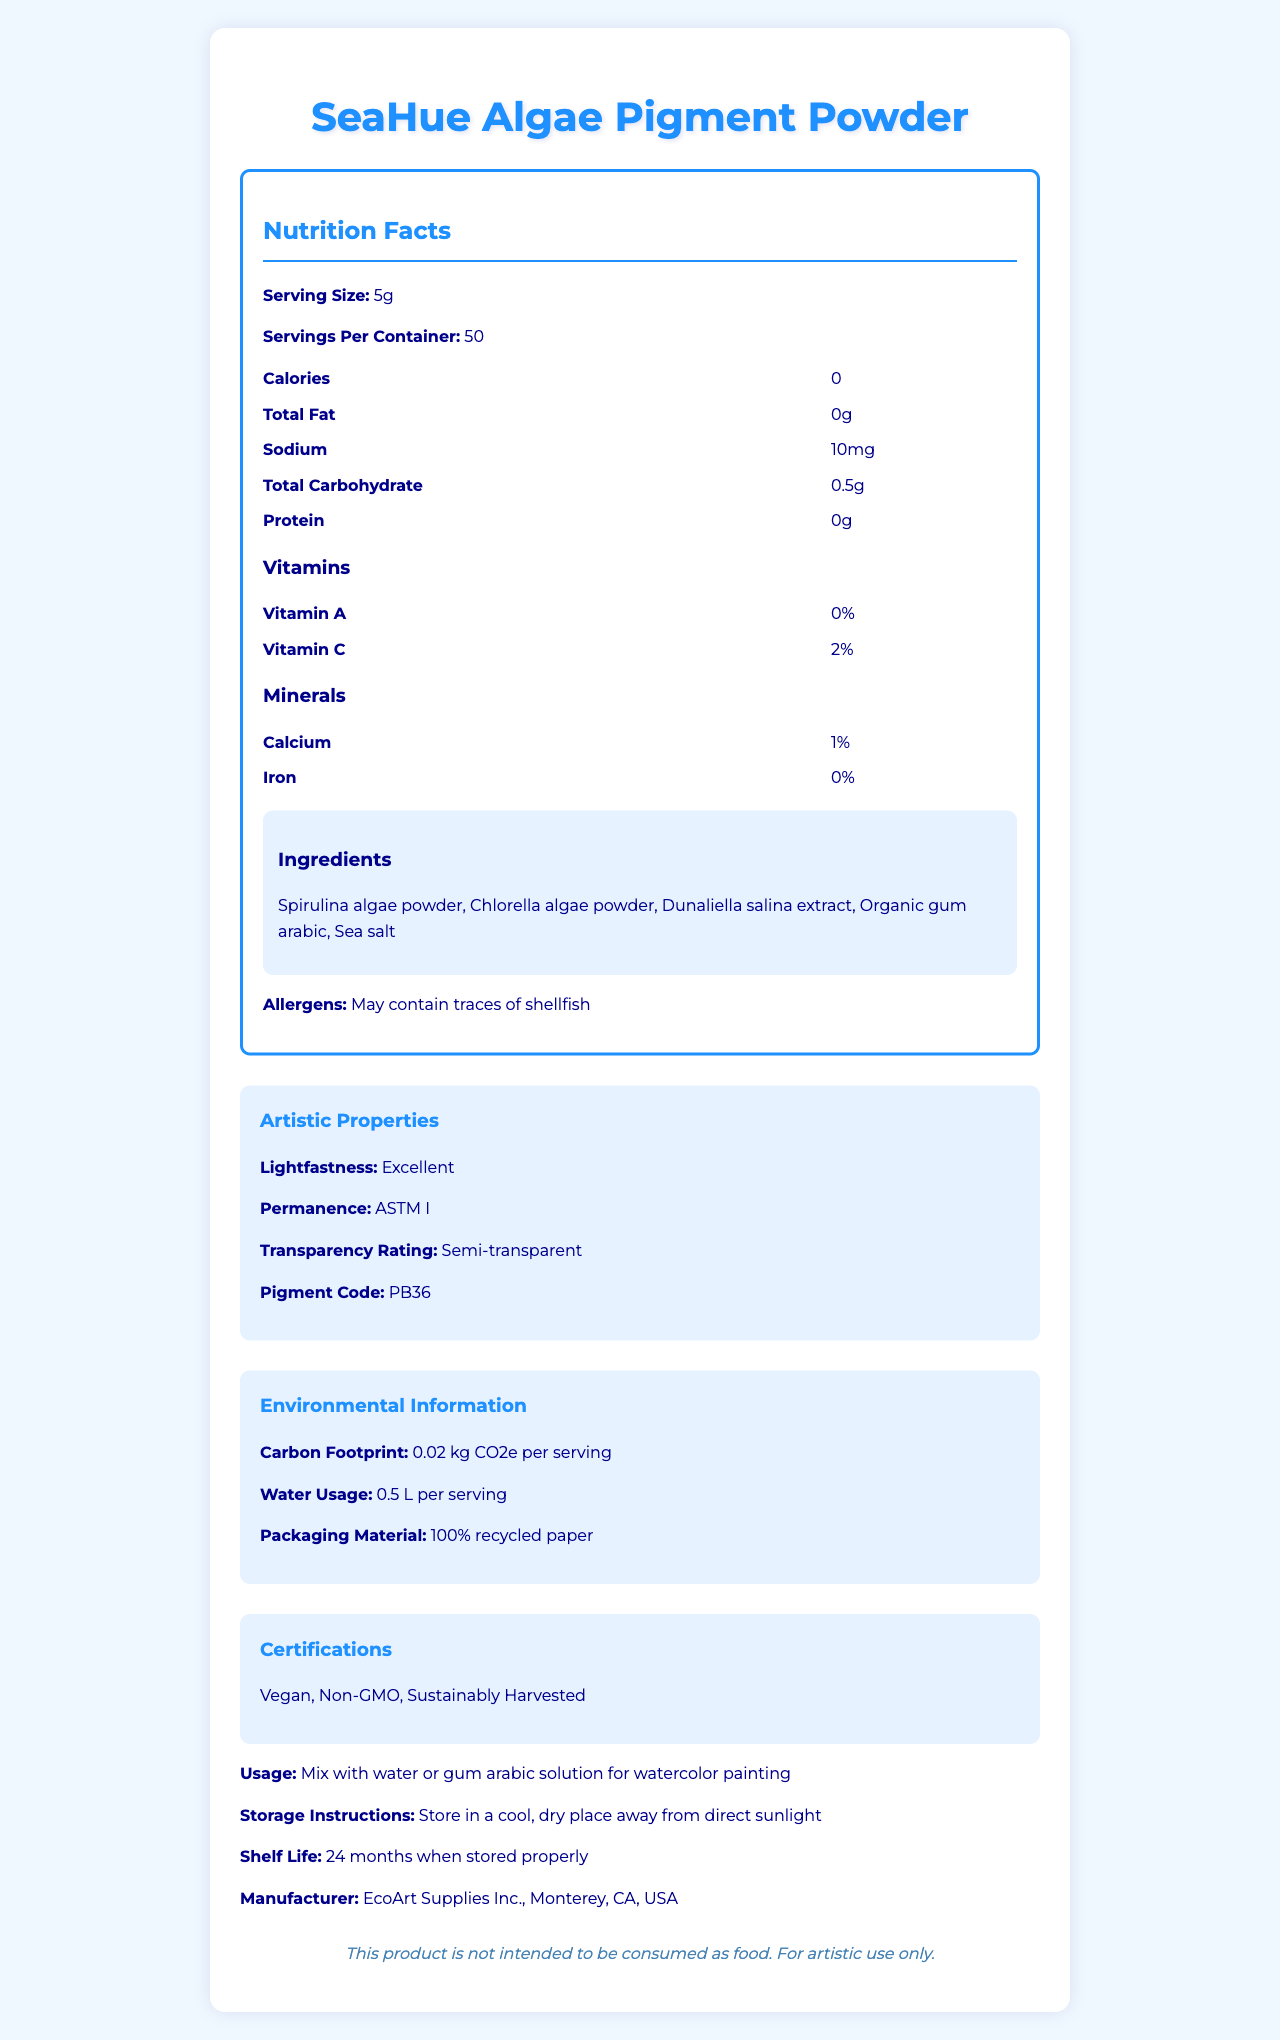What is the serving size of SeaHue Algae Pigment Powder? The serving size is explicitly mentioned in the document as "Serving Size: 5g".
Answer: 5g How many servings are there per container? The document states "Servings Per Container: 50".
Answer: 50 What is the sodium content per serving? The sodium content is listed in the nutrition facts as "Sodium: 10mg".
Answer: 10mg Which vitamins and minerals are present in SeaHue Algae Pigment Powder? The document specifies the presence of vitamins and minerals under separate headings. Vitamin C is 2%, Calcium is 1%, and Iron is 0%.
Answer: Vitamin C (2%), Calcium (1%), Iron (0%) What is the suggested usage for SeaHue Algae Pigment Powder? This is given in the "Usage" section of the document.
Answer: Mix with water or gum arabic solution for watercolor painting What is the lightfastness rating of this pigment? This is listed under the "Artistic Properties" section.
Answer: Excellent What is the transparency rating of SeaHue Algae Pigment Powder? The transparency rating is mentioned in the Artistic Properties section as "Transparency Rating: Semi-transparent".
Answer: Semi-transparent What materials are used in the packaging of SeaHue Algae Pigment Powder? A. Plastic B. Recycled Paper C. Metal The packaging material is stated as "100% recycled paper" under the "Environmental Information" section.
Answer: B Which of the following is NOT an ingredient in the SeaHue Algae Pigment Powder? A. Spirulina algae powder B. Chlorella algae powder C. Tartrazine D. Dunaliella salina extract The listed ingredients are Spirulina algae powder, Chlorella algae powder, Dunaliella salina extract, Organic gum arabic, and Sea salt; Tartrazine is not mentioned.
Answer: C Is SeaHue Algae Pigment Powder intended for food consumption? The disclaimer clearly states, "This product is not intended to be consumed as food."
Answer: No Does the document say if SeaHue Algae Pigment Powder contains Vitamin B12? The document does not mention Vitamin B12 at all, so there is no information available on its presence.
Answer: Cannot be determined Summarize the main purpose of the document. The document contains various sections related to nutritional facts, artistic properties, ingredients, allergens, environmental information, certifications, usage, storage instructions, and manufacturer details which provide a comprehensive overview of the SeaHue Algae Pigment Powder.
Answer: To provide detailed information on the nutritional, environmental, artistic properties, and certifications of SeaHue Algae Pigment Powder, emphasizing its eco-friendly and artistic use. What is the manufacturer's location for SeaHue Algae Pigment Powder? The location of the manufacturer, EcoArt Supplies Inc., is mentioned as Monterey, CA, USA.
Answer: Monterey, CA, USA What is the carbon footprint per serving of SeaHue Algae Pigment Powder? The carbon footprint is specified in the "Environmental Information" section as "0.02 kg CO2e per serving".
Answer: 0.02 kg CO2e per serving Name a potential allergen that may be present in SeaHue Algae Pigment Powder. The "Allergens" section states, "May contain traces of shellfish".
Answer: Shellfish 